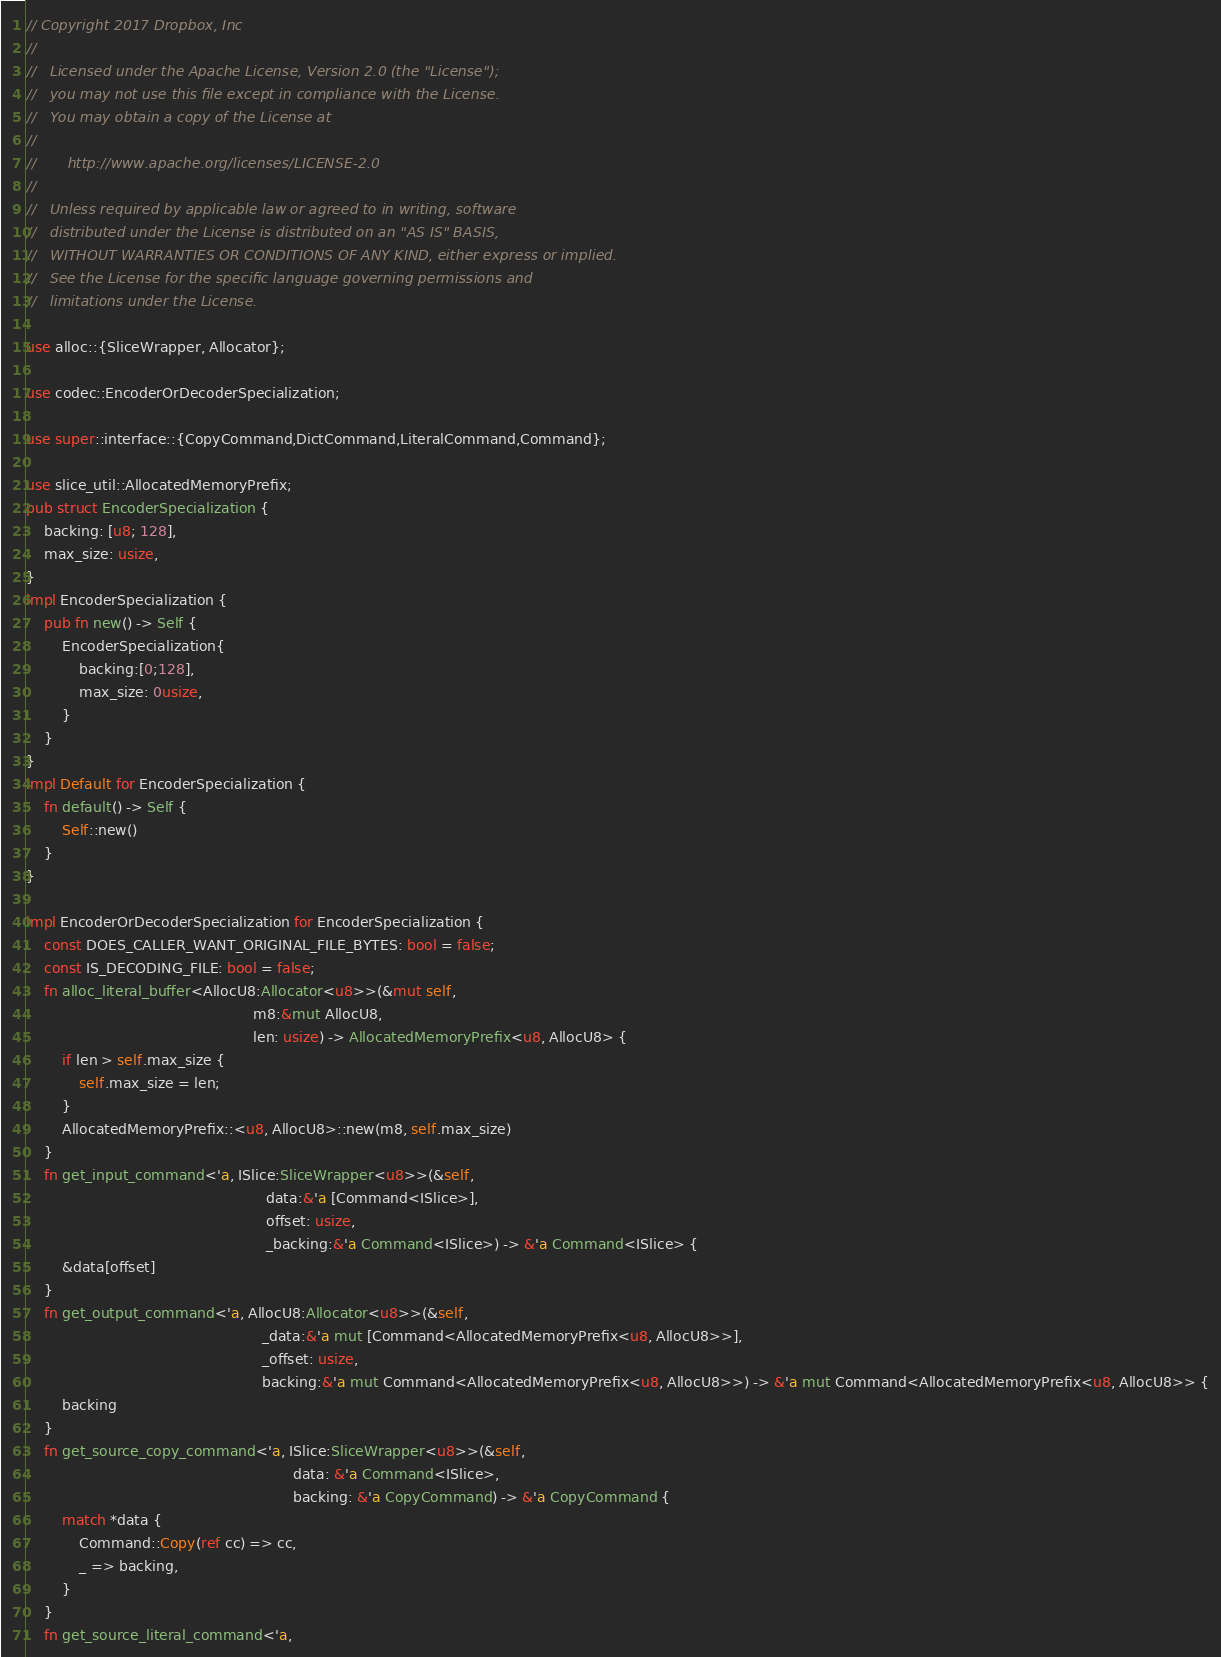<code> <loc_0><loc_0><loc_500><loc_500><_Rust_>// Copyright 2017 Dropbox, Inc
//
//   Licensed under the Apache License, Version 2.0 (the "License");
//   you may not use this file except in compliance with the License.
//   You may obtain a copy of the License at
//
//       http://www.apache.org/licenses/LICENSE-2.0
//
//   Unless required by applicable law or agreed to in writing, software
//   distributed under the License is distributed on an "AS IS" BASIS,
//   WITHOUT WARRANTIES OR CONDITIONS OF ANY KIND, either express or implied.
//   See the License for the specific language governing permissions and
//   limitations under the License.

use alloc::{SliceWrapper, Allocator};

use codec::EncoderOrDecoderSpecialization;

use super::interface::{CopyCommand,DictCommand,LiteralCommand,Command};

use slice_util::AllocatedMemoryPrefix;
pub struct EncoderSpecialization {
    backing: [u8; 128],
    max_size: usize,
}
impl EncoderSpecialization {
    pub fn new() -> Self {
        EncoderSpecialization{
            backing:[0;128],
            max_size: 0usize,
        }
    }
}
impl Default for EncoderSpecialization {
    fn default() -> Self {
        Self::new()
    }
}

impl EncoderOrDecoderSpecialization for EncoderSpecialization {
    const DOES_CALLER_WANT_ORIGINAL_FILE_BYTES: bool = false;
    const IS_DECODING_FILE: bool = false;
    fn alloc_literal_buffer<AllocU8:Allocator<u8>>(&mut self,
                                                   m8:&mut AllocU8,
                                                   len: usize) -> AllocatedMemoryPrefix<u8, AllocU8> {
        if len > self.max_size {
            self.max_size = len;
        }
        AllocatedMemoryPrefix::<u8, AllocU8>::new(m8, self.max_size)
    }
    fn get_input_command<'a, ISlice:SliceWrapper<u8>>(&self,
                                                      data:&'a [Command<ISlice>],
                                                      offset: usize,
                                                      _backing:&'a Command<ISlice>) -> &'a Command<ISlice> {
        &data[offset]
    }
    fn get_output_command<'a, AllocU8:Allocator<u8>>(&self,
                                                     _data:&'a mut [Command<AllocatedMemoryPrefix<u8, AllocU8>>],
                                                     _offset: usize,
                                                     backing:&'a mut Command<AllocatedMemoryPrefix<u8, AllocU8>>) -> &'a mut Command<AllocatedMemoryPrefix<u8, AllocU8>> {
        backing
    }
    fn get_source_copy_command<'a, ISlice:SliceWrapper<u8>>(&self,
                                                            data: &'a Command<ISlice>,
                                                            backing: &'a CopyCommand) -> &'a CopyCommand {
        match *data {
            Command::Copy(ref cc) => cc,
            _ => backing,
        }
    }
    fn get_source_literal_command<'a,</code> 